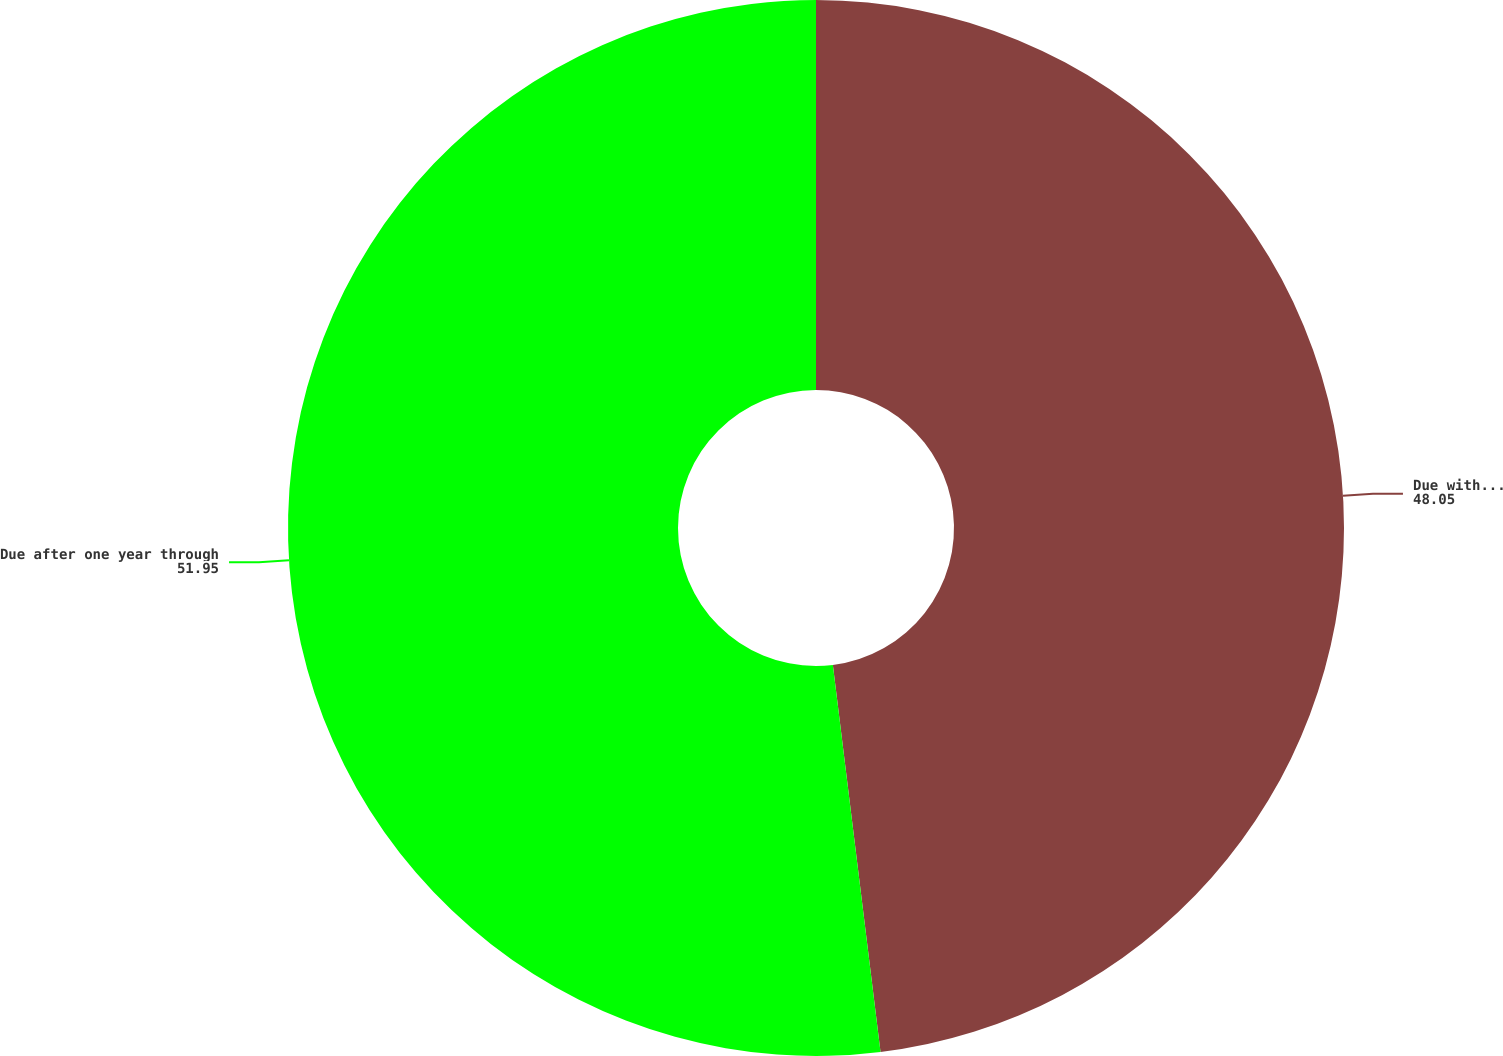Convert chart to OTSL. <chart><loc_0><loc_0><loc_500><loc_500><pie_chart><fcel>Due within one year<fcel>Due after one year through<nl><fcel>48.05%<fcel>51.95%<nl></chart> 